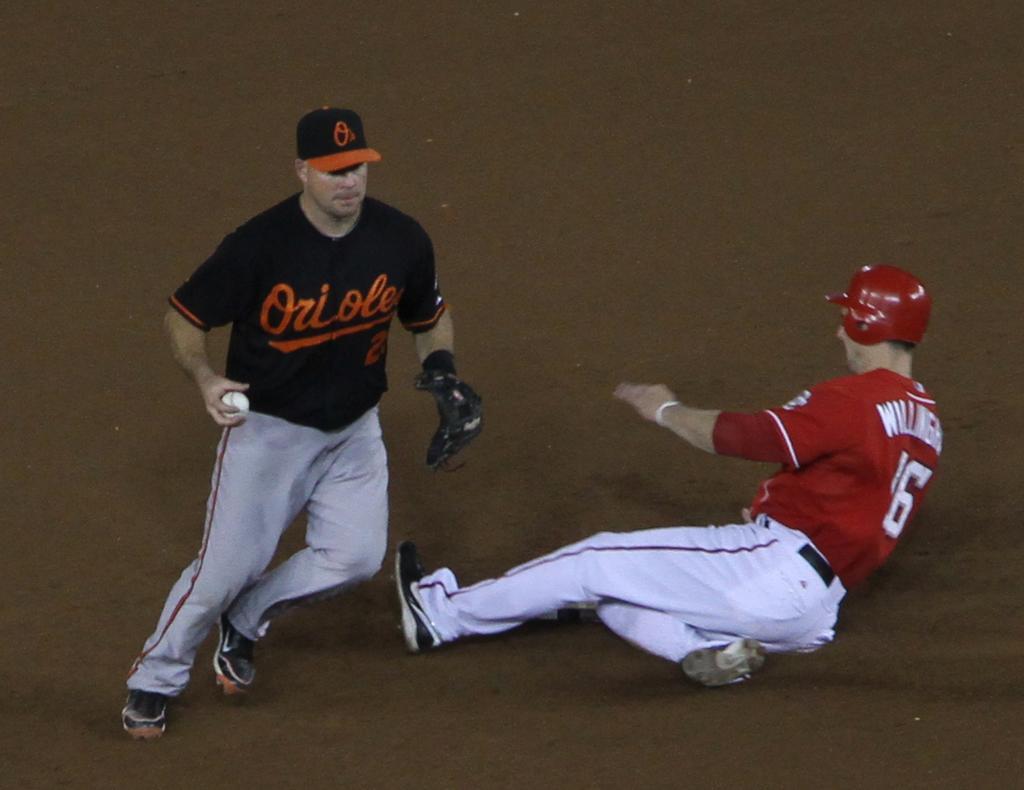Please provide a concise description of this image. In the image there are two players,one person is lying on the ground and the second person is running,the person is holding a ball in his right hand and he is wearing a glove to his left hand. 